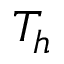Convert formula to latex. <formula><loc_0><loc_0><loc_500><loc_500>T _ { h }</formula> 